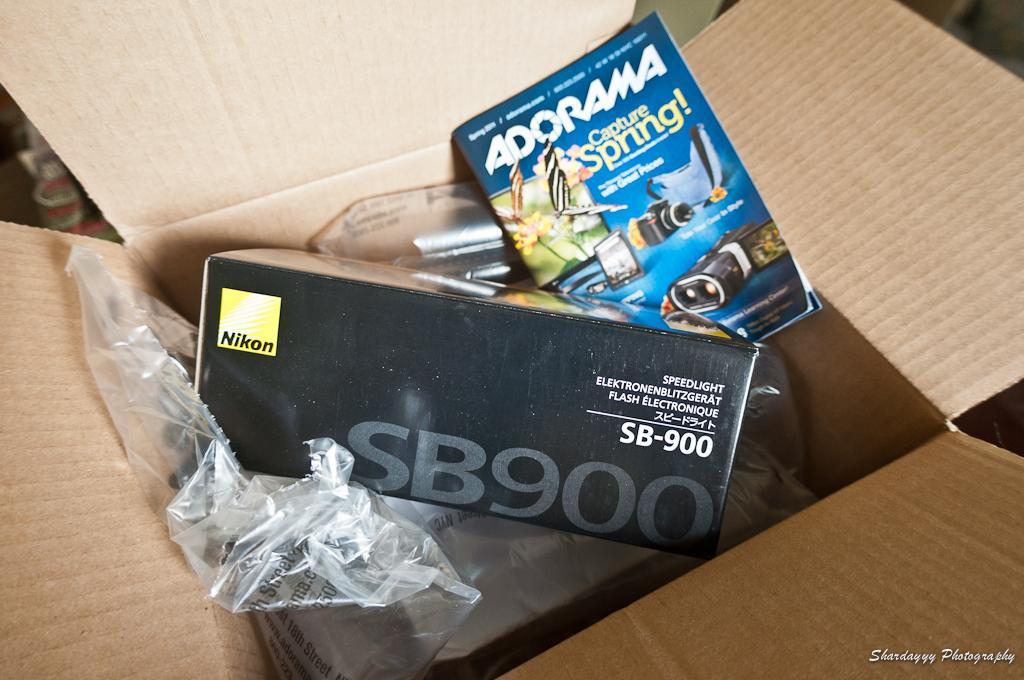Please provide a concise description of this image. In this picture we can see a book, box and plastic covers in a cardboard box. On the image there is a watermark. 